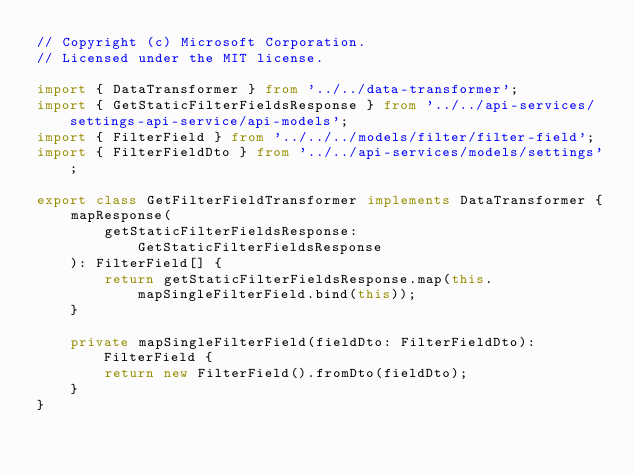<code> <loc_0><loc_0><loc_500><loc_500><_TypeScript_>// Copyright (c) Microsoft Corporation.
// Licensed under the MIT license.

import { DataTransformer } from '../../data-transformer';
import { GetStaticFilterFieldsResponse } from '../../api-services/settings-api-service/api-models';
import { FilterField } from '../../../models/filter/filter-field';
import { FilterFieldDto } from '../../api-services/models/settings';

export class GetFilterFieldTransformer implements DataTransformer {
    mapResponse(
        getStaticFilterFieldsResponse: GetStaticFilterFieldsResponse
    ): FilterField[] {
        return getStaticFilterFieldsResponse.map(this.mapSingleFilterField.bind(this));
    }

    private mapSingleFilterField(fieldDto: FilterFieldDto): FilterField {
        return new FilterField().fromDto(fieldDto);
    }
}
</code> 